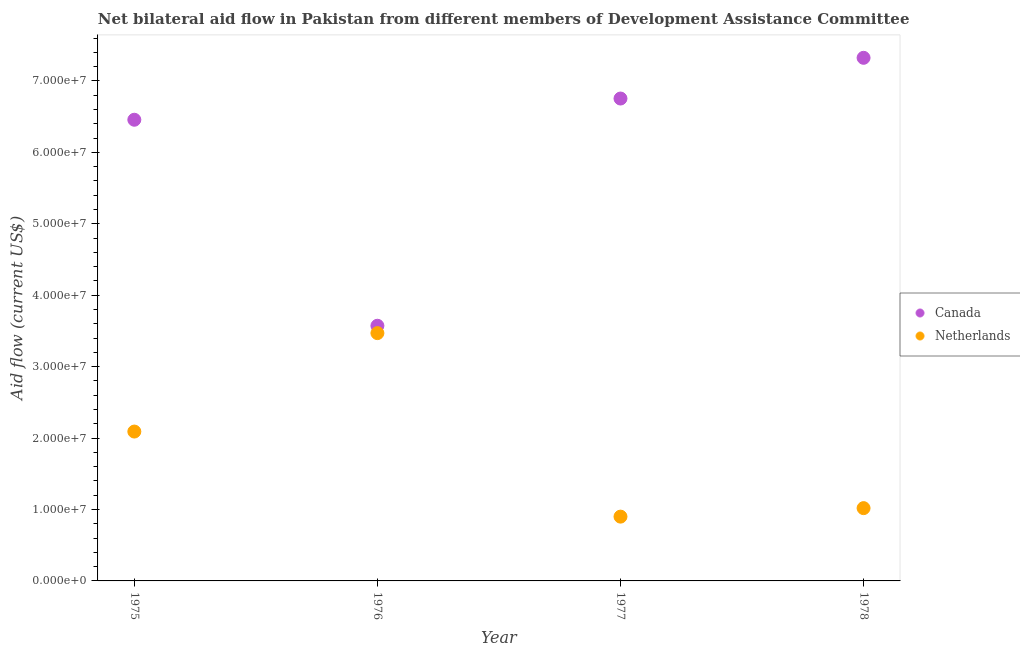How many different coloured dotlines are there?
Provide a succinct answer. 2. What is the amount of aid given by canada in 1977?
Offer a very short reply. 6.75e+07. Across all years, what is the maximum amount of aid given by canada?
Your answer should be compact. 7.32e+07. Across all years, what is the minimum amount of aid given by netherlands?
Provide a succinct answer. 9.00e+06. In which year was the amount of aid given by canada maximum?
Your answer should be very brief. 1978. In which year was the amount of aid given by netherlands minimum?
Provide a short and direct response. 1977. What is the total amount of aid given by netherlands in the graph?
Your answer should be very brief. 7.48e+07. What is the difference between the amount of aid given by netherlands in 1976 and that in 1978?
Give a very brief answer. 2.45e+07. What is the difference between the amount of aid given by canada in 1976 and the amount of aid given by netherlands in 1977?
Make the answer very short. 2.67e+07. What is the average amount of aid given by netherlands per year?
Offer a terse response. 1.87e+07. In the year 1978, what is the difference between the amount of aid given by netherlands and amount of aid given by canada?
Provide a short and direct response. -6.30e+07. What is the ratio of the amount of aid given by netherlands in 1975 to that in 1977?
Give a very brief answer. 2.32. Is the amount of aid given by netherlands in 1975 less than that in 1977?
Your answer should be very brief. No. Is the difference between the amount of aid given by netherlands in 1976 and 1977 greater than the difference between the amount of aid given by canada in 1976 and 1977?
Ensure brevity in your answer.  Yes. What is the difference between the highest and the second highest amount of aid given by canada?
Offer a very short reply. 5.70e+06. What is the difference between the highest and the lowest amount of aid given by canada?
Ensure brevity in your answer.  3.75e+07. In how many years, is the amount of aid given by netherlands greater than the average amount of aid given by netherlands taken over all years?
Your answer should be very brief. 2. Does the amount of aid given by netherlands monotonically increase over the years?
Offer a very short reply. No. Is the amount of aid given by netherlands strictly greater than the amount of aid given by canada over the years?
Your response must be concise. No. Is the amount of aid given by netherlands strictly less than the amount of aid given by canada over the years?
Give a very brief answer. Yes. How many dotlines are there?
Offer a very short reply. 2. How many years are there in the graph?
Provide a succinct answer. 4. Are the values on the major ticks of Y-axis written in scientific E-notation?
Give a very brief answer. Yes. Does the graph contain grids?
Ensure brevity in your answer.  No. Where does the legend appear in the graph?
Your answer should be compact. Center right. What is the title of the graph?
Your response must be concise. Net bilateral aid flow in Pakistan from different members of Development Assistance Committee. Does "Goods" appear as one of the legend labels in the graph?
Your answer should be compact. No. What is the label or title of the X-axis?
Provide a short and direct response. Year. What is the Aid flow (current US$) of Canada in 1975?
Ensure brevity in your answer.  6.46e+07. What is the Aid flow (current US$) in Netherlands in 1975?
Offer a terse response. 2.09e+07. What is the Aid flow (current US$) in Canada in 1976?
Keep it short and to the point. 3.57e+07. What is the Aid flow (current US$) of Netherlands in 1976?
Make the answer very short. 3.47e+07. What is the Aid flow (current US$) of Canada in 1977?
Offer a very short reply. 6.75e+07. What is the Aid flow (current US$) in Netherlands in 1977?
Your answer should be compact. 9.00e+06. What is the Aid flow (current US$) of Canada in 1978?
Provide a succinct answer. 7.32e+07. What is the Aid flow (current US$) of Netherlands in 1978?
Your response must be concise. 1.02e+07. Across all years, what is the maximum Aid flow (current US$) in Canada?
Your answer should be very brief. 7.32e+07. Across all years, what is the maximum Aid flow (current US$) in Netherlands?
Your answer should be compact. 3.47e+07. Across all years, what is the minimum Aid flow (current US$) of Canada?
Provide a short and direct response. 3.57e+07. Across all years, what is the minimum Aid flow (current US$) of Netherlands?
Make the answer very short. 9.00e+06. What is the total Aid flow (current US$) in Canada in the graph?
Give a very brief answer. 2.41e+08. What is the total Aid flow (current US$) of Netherlands in the graph?
Your answer should be very brief. 7.48e+07. What is the difference between the Aid flow (current US$) of Canada in 1975 and that in 1976?
Give a very brief answer. 2.88e+07. What is the difference between the Aid flow (current US$) in Netherlands in 1975 and that in 1976?
Provide a succinct answer. -1.38e+07. What is the difference between the Aid flow (current US$) of Canada in 1975 and that in 1977?
Your answer should be compact. -2.97e+06. What is the difference between the Aid flow (current US$) of Netherlands in 1975 and that in 1977?
Offer a very short reply. 1.19e+07. What is the difference between the Aid flow (current US$) of Canada in 1975 and that in 1978?
Keep it short and to the point. -8.67e+06. What is the difference between the Aid flow (current US$) in Netherlands in 1975 and that in 1978?
Give a very brief answer. 1.07e+07. What is the difference between the Aid flow (current US$) of Canada in 1976 and that in 1977?
Provide a short and direct response. -3.18e+07. What is the difference between the Aid flow (current US$) of Netherlands in 1976 and that in 1977?
Your answer should be compact. 2.57e+07. What is the difference between the Aid flow (current US$) in Canada in 1976 and that in 1978?
Provide a short and direct response. -3.75e+07. What is the difference between the Aid flow (current US$) in Netherlands in 1976 and that in 1978?
Your answer should be compact. 2.45e+07. What is the difference between the Aid flow (current US$) of Canada in 1977 and that in 1978?
Your answer should be very brief. -5.70e+06. What is the difference between the Aid flow (current US$) of Netherlands in 1977 and that in 1978?
Ensure brevity in your answer.  -1.19e+06. What is the difference between the Aid flow (current US$) of Canada in 1975 and the Aid flow (current US$) of Netherlands in 1976?
Provide a succinct answer. 2.99e+07. What is the difference between the Aid flow (current US$) in Canada in 1975 and the Aid flow (current US$) in Netherlands in 1977?
Offer a terse response. 5.56e+07. What is the difference between the Aid flow (current US$) of Canada in 1975 and the Aid flow (current US$) of Netherlands in 1978?
Your answer should be compact. 5.44e+07. What is the difference between the Aid flow (current US$) in Canada in 1976 and the Aid flow (current US$) in Netherlands in 1977?
Offer a terse response. 2.67e+07. What is the difference between the Aid flow (current US$) in Canada in 1976 and the Aid flow (current US$) in Netherlands in 1978?
Your answer should be very brief. 2.55e+07. What is the difference between the Aid flow (current US$) of Canada in 1977 and the Aid flow (current US$) of Netherlands in 1978?
Offer a very short reply. 5.73e+07. What is the average Aid flow (current US$) in Canada per year?
Provide a succinct answer. 6.03e+07. What is the average Aid flow (current US$) in Netherlands per year?
Provide a succinct answer. 1.87e+07. In the year 1975, what is the difference between the Aid flow (current US$) in Canada and Aid flow (current US$) in Netherlands?
Offer a very short reply. 4.36e+07. In the year 1976, what is the difference between the Aid flow (current US$) of Canada and Aid flow (current US$) of Netherlands?
Offer a terse response. 1.03e+06. In the year 1977, what is the difference between the Aid flow (current US$) in Canada and Aid flow (current US$) in Netherlands?
Your response must be concise. 5.85e+07. In the year 1978, what is the difference between the Aid flow (current US$) in Canada and Aid flow (current US$) in Netherlands?
Offer a terse response. 6.30e+07. What is the ratio of the Aid flow (current US$) of Canada in 1975 to that in 1976?
Ensure brevity in your answer.  1.81. What is the ratio of the Aid flow (current US$) of Netherlands in 1975 to that in 1976?
Ensure brevity in your answer.  0.6. What is the ratio of the Aid flow (current US$) in Canada in 1975 to that in 1977?
Provide a succinct answer. 0.96. What is the ratio of the Aid flow (current US$) in Netherlands in 1975 to that in 1977?
Make the answer very short. 2.32. What is the ratio of the Aid flow (current US$) of Canada in 1975 to that in 1978?
Your answer should be compact. 0.88. What is the ratio of the Aid flow (current US$) of Netherlands in 1975 to that in 1978?
Provide a short and direct response. 2.05. What is the ratio of the Aid flow (current US$) in Canada in 1976 to that in 1977?
Your response must be concise. 0.53. What is the ratio of the Aid flow (current US$) in Netherlands in 1976 to that in 1977?
Your response must be concise. 3.85. What is the ratio of the Aid flow (current US$) in Canada in 1976 to that in 1978?
Provide a short and direct response. 0.49. What is the ratio of the Aid flow (current US$) in Netherlands in 1976 to that in 1978?
Make the answer very short. 3.4. What is the ratio of the Aid flow (current US$) of Canada in 1977 to that in 1978?
Provide a short and direct response. 0.92. What is the ratio of the Aid flow (current US$) of Netherlands in 1977 to that in 1978?
Make the answer very short. 0.88. What is the difference between the highest and the second highest Aid flow (current US$) in Canada?
Keep it short and to the point. 5.70e+06. What is the difference between the highest and the second highest Aid flow (current US$) in Netherlands?
Offer a very short reply. 1.38e+07. What is the difference between the highest and the lowest Aid flow (current US$) of Canada?
Make the answer very short. 3.75e+07. What is the difference between the highest and the lowest Aid flow (current US$) of Netherlands?
Make the answer very short. 2.57e+07. 